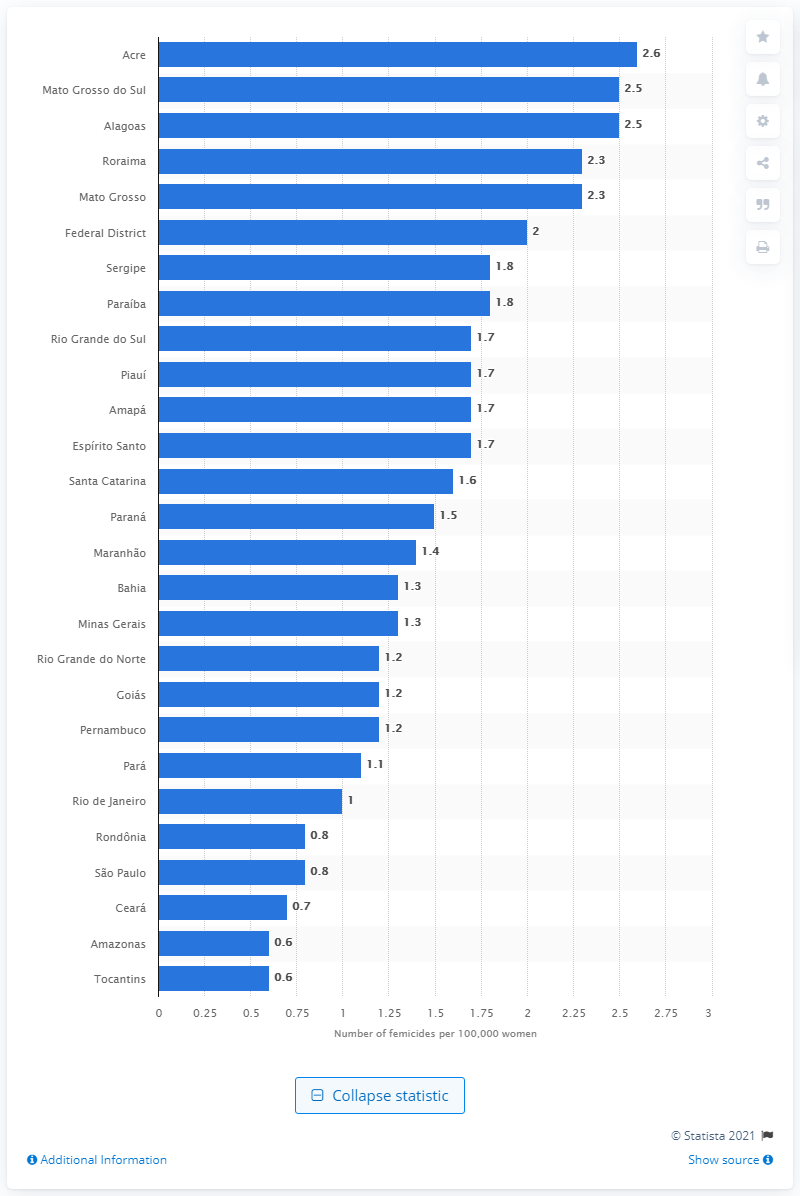List a handful of essential elements in this visual. In 2019, Mato Grosso do Sul had the highest femicide rates among all Brazilian states. The average femicide rate per 100,000 women in Brazil was 1.2. According to data, the femicide rate in Roraima and Mato Grosso was 2.3 per 100,000 people in the year 2021. Out of every 100,000 women who lived in Acre and Alagoas, approximately 2.5% were murdered on account of their gender. 